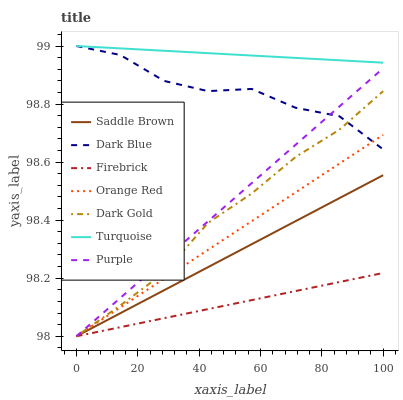Does Firebrick have the minimum area under the curve?
Answer yes or no. Yes. Does Turquoise have the maximum area under the curve?
Answer yes or no. Yes. Does Dark Gold have the minimum area under the curve?
Answer yes or no. No. Does Dark Gold have the maximum area under the curve?
Answer yes or no. No. Is Firebrick the smoothest?
Answer yes or no. Yes. Is Dark Blue the roughest?
Answer yes or no. Yes. Is Dark Gold the smoothest?
Answer yes or no. No. Is Dark Gold the roughest?
Answer yes or no. No. Does Dark Gold have the lowest value?
Answer yes or no. Yes. Does Dark Blue have the lowest value?
Answer yes or no. No. Does Dark Blue have the highest value?
Answer yes or no. Yes. Does Dark Gold have the highest value?
Answer yes or no. No. Is Firebrick less than Turquoise?
Answer yes or no. Yes. Is Turquoise greater than Purple?
Answer yes or no. Yes. Does Turquoise intersect Dark Blue?
Answer yes or no. Yes. Is Turquoise less than Dark Blue?
Answer yes or no. No. Is Turquoise greater than Dark Blue?
Answer yes or no. No. Does Firebrick intersect Turquoise?
Answer yes or no. No. 